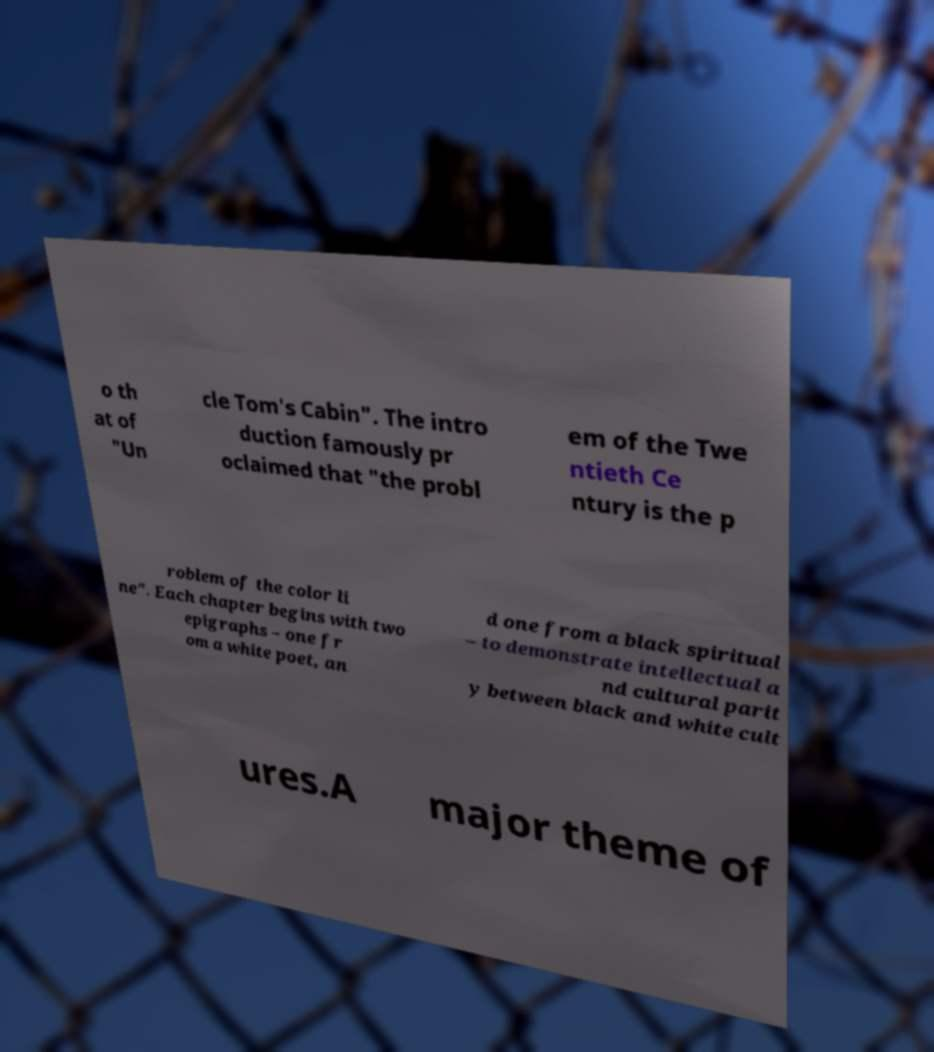Can you accurately transcribe the text from the provided image for me? o th at of "Un cle Tom's Cabin". The intro duction famously pr oclaimed that "the probl em of the Twe ntieth Ce ntury is the p roblem of the color li ne". Each chapter begins with two epigraphs – one fr om a white poet, an d one from a black spiritual – to demonstrate intellectual a nd cultural parit y between black and white cult ures.A major theme of 